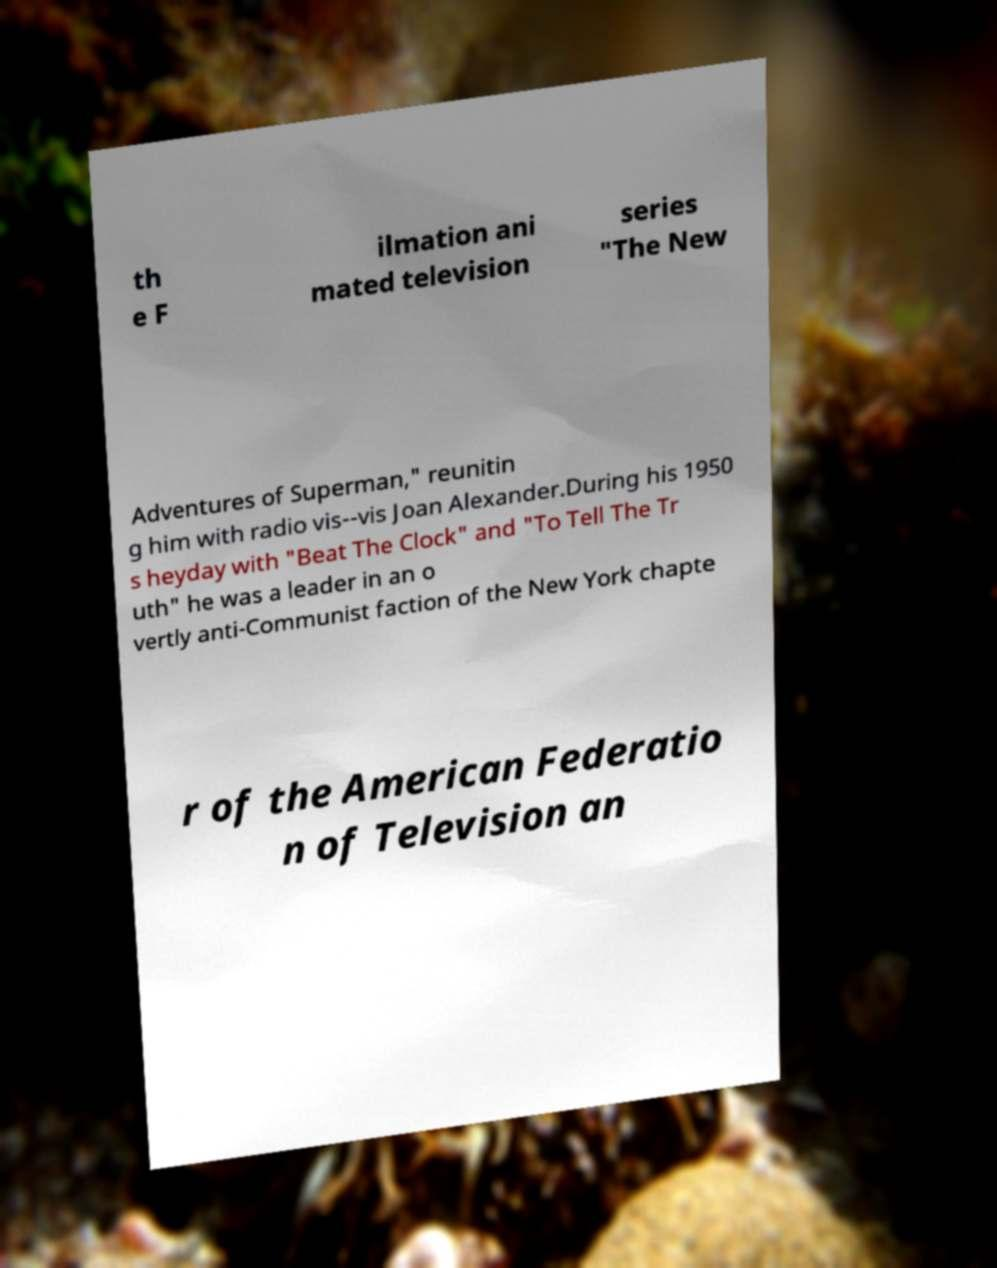Please identify and transcribe the text found in this image. th e F ilmation ani mated television series "The New Adventures of Superman," reunitin g him with radio vis--vis Joan Alexander.During his 1950 s heyday with "Beat The Clock" and "To Tell The Tr uth" he was a leader in an o vertly anti-Communist faction of the New York chapte r of the American Federatio n of Television an 